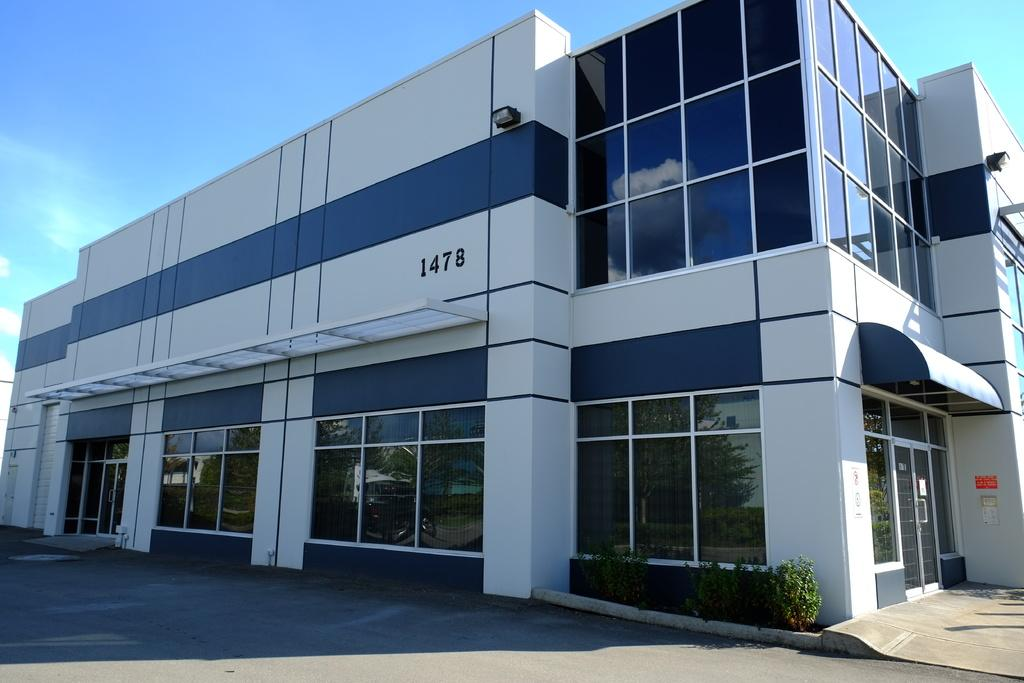What type of structure is present in the image? There is a building in the image. What features can be seen on the building? The building has windows and doors. What other elements are present in the image besides the building? There are trees, a path, and the sky visible in the image. What is the condition of the sky in the image? The sky is visible in the background of the image, and there are clouds in the sky. What is the price of the cable seen in the image? There is no cable present in the image, so it is not possible to determine its price. 